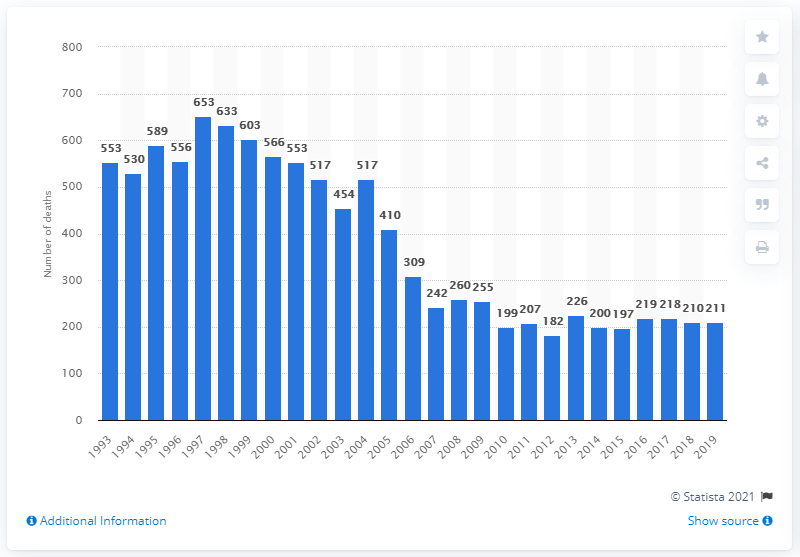List a handful of essential elements in this visual. In 2019, there were 211 recorded deaths in England and Wales as a result of paracetamol poisoning. In 1997, there were 653 deaths caused by paracetamol. 